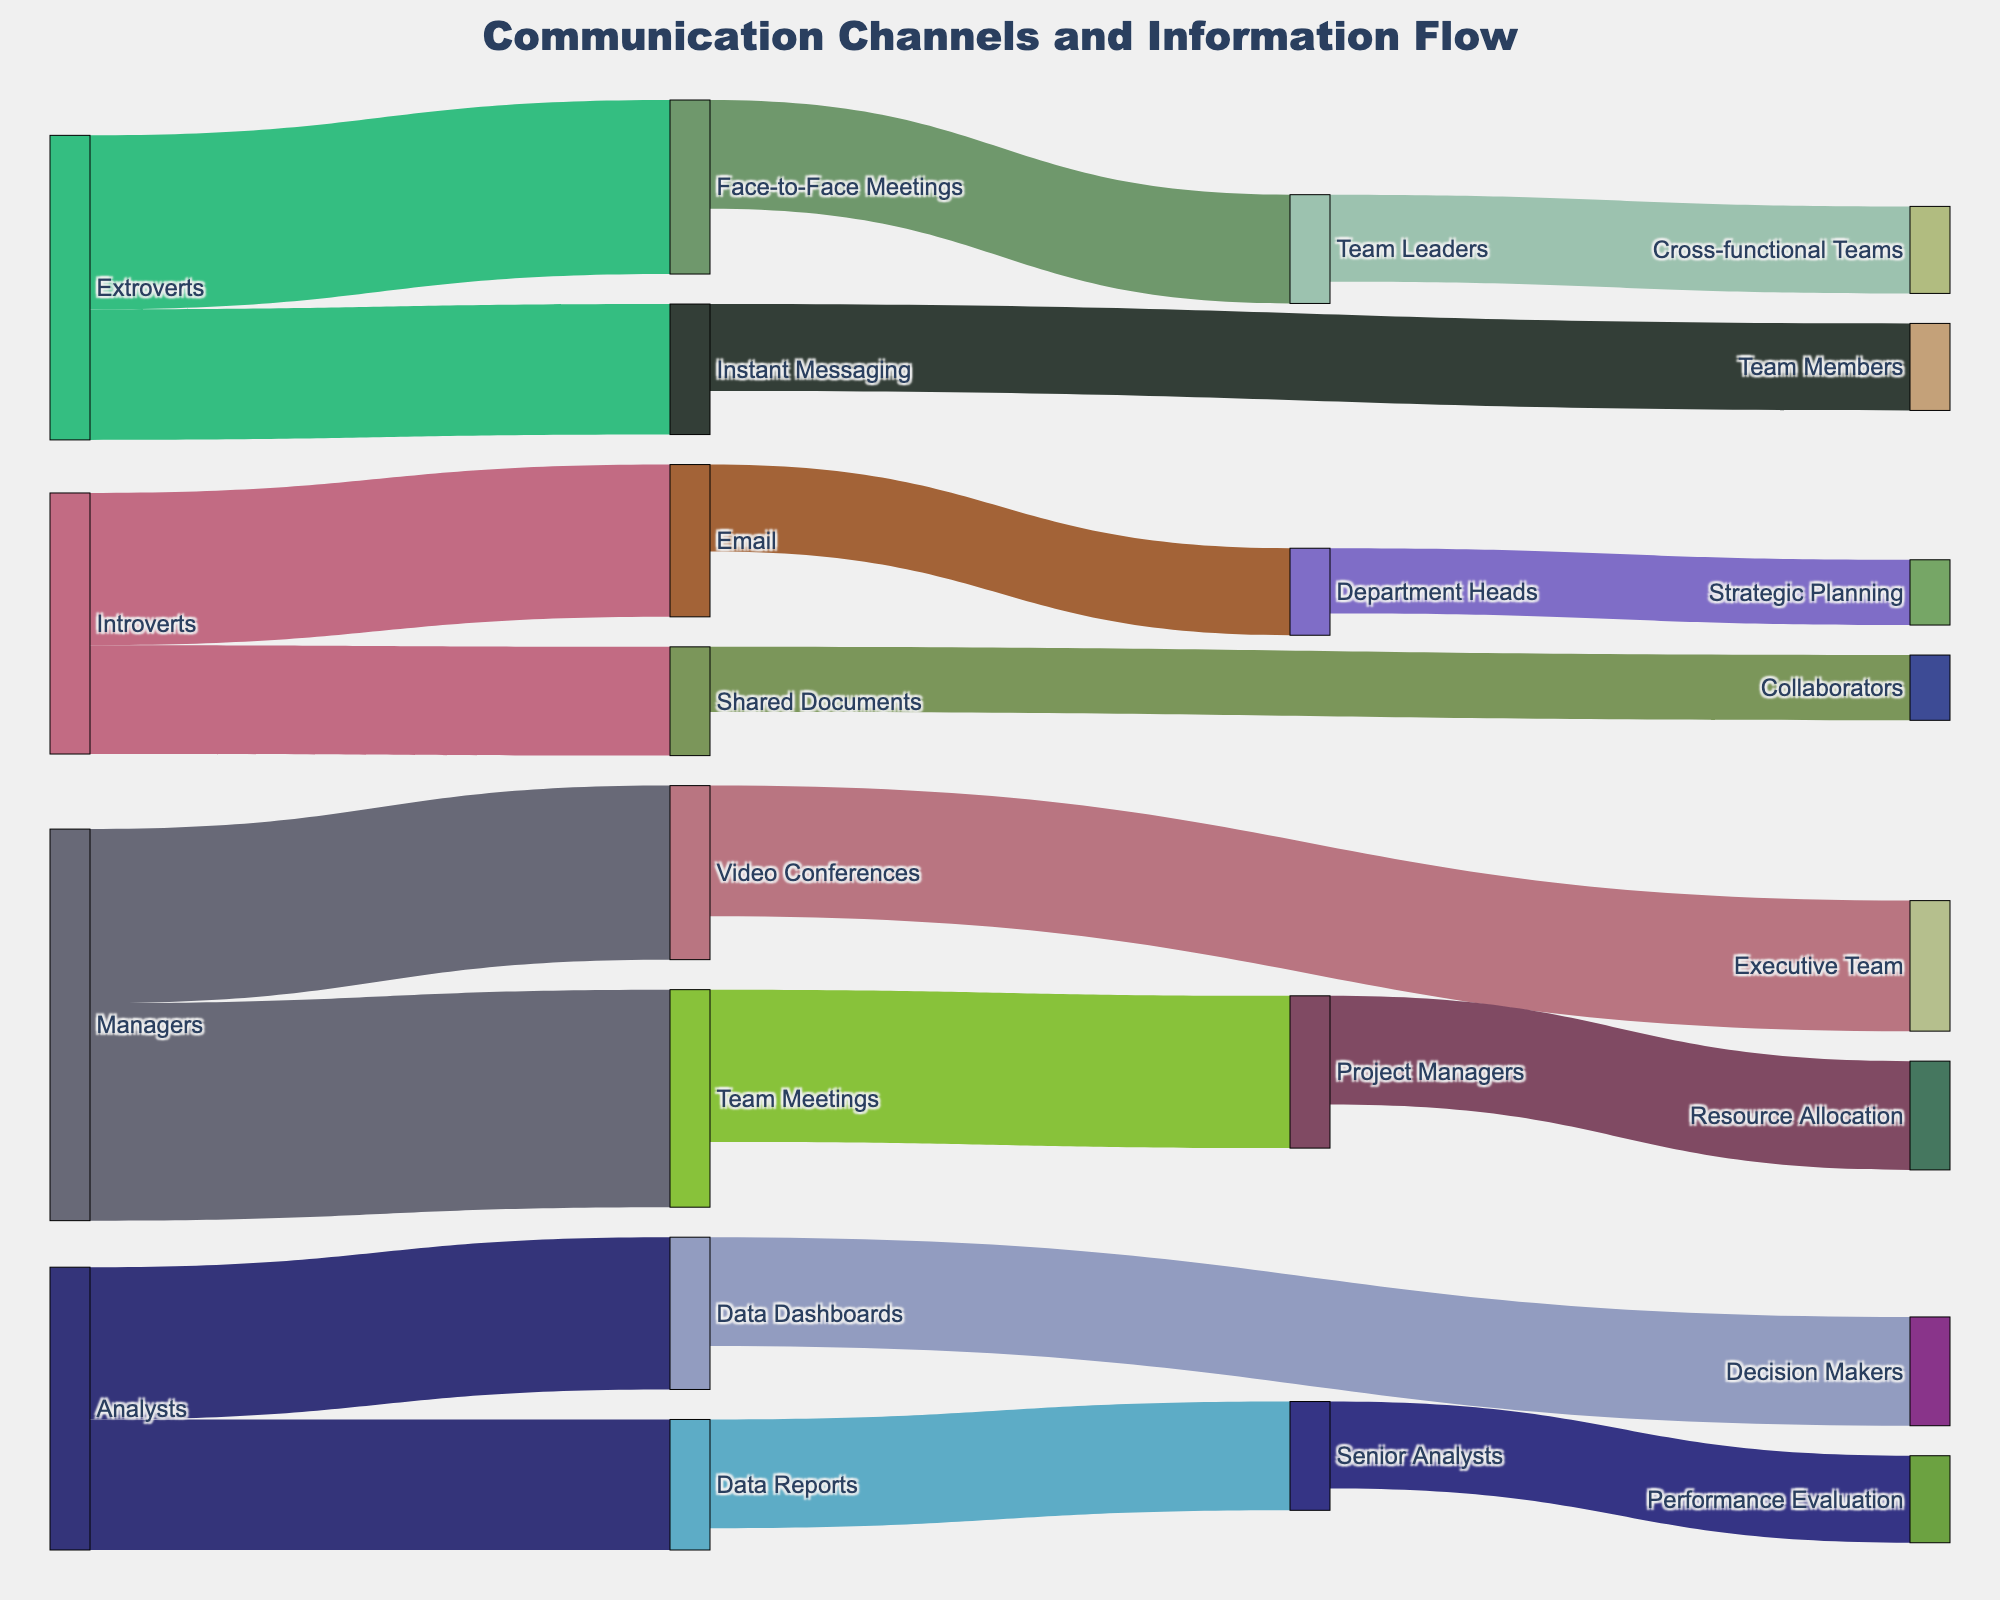How many communication channels are primarily used by extroverts? To find this, locate the nodes directly connected to 'Extroverts'. There are two connections: 'Face-to-Face Meetings' and 'Instant Messaging'.
Answer: 2 Which hierarchical level receives the most information from 'Video Conferences'? Look at the nodes connected to 'Video Conferences'. 'Executive Team' receives 30 units of information, which is the highest.
Answer: Executive Team What is the total value of information shared by managers? Identify all nodes sourcing from 'Managers': 'Team Meetings' (50) and 'Video Conferences' (40). Summing these gives 90.
Answer: 90 Do introverts receive more communication through 'Email' or 'Shared Documents'? Compare the values connected to introverts: 'Email' (35) and 'Shared Documents' (25). 'Email' is greater than 'Shared Documents'.
Answer: Email Which has more information flow, 'Face-to-Face Meetings' or 'Instant Messaging'? 'Face-to-Face Meetings' has connections with values of 40 and 25, totaling 65. 'Instant Messaging' has connections with values of 30 and 20, totaling 50. 'Face-to-Face Meetings' has more.
Answer: Face-to-Face Meetings How much information do 'Senior Analysts' receive from 'Data Reports'? Look at the direct connection from 'Data Reports' to 'Senior Analysts', which is 25.
Answer: 25 What is the combined information flow from 'Analysts'? Identify connections from 'Analysts': 'Data Reports' (30) and 'Data Dashboards' (35). The total is 65.
Answer: 65 What type of meeting is preferred by more hierarchical levels: 'Team Meetings' or 'Video Conferences'? 'Team Meetings' connect to one level ('Project Managers'), while 'Video Conferences' connect to two levels ('Executive Team' and a lower level not fully specified).
Answer: Video Conferences 